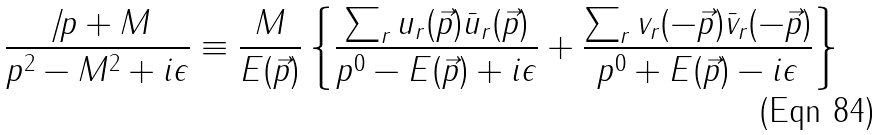<formula> <loc_0><loc_0><loc_500><loc_500>\frac { \not \, p + M } { p ^ { 2 } - M ^ { 2 } + i \epsilon } \equiv \frac { M } { E ( \vec { p } ) } \left \{ \frac { \sum _ { r } u _ { r } ( \vec { p } ) \bar { u } _ { r } ( \vec { p } ) } { p ^ { 0 } - E ( \vec { p } ) + i \epsilon } + \frac { \sum _ { r } v _ { r } ( - \vec { p } ) \bar { v } _ { r } ( - \vec { p } ) } { p ^ { 0 } + E ( \vec { p } ) - i \epsilon } \right \}</formula> 